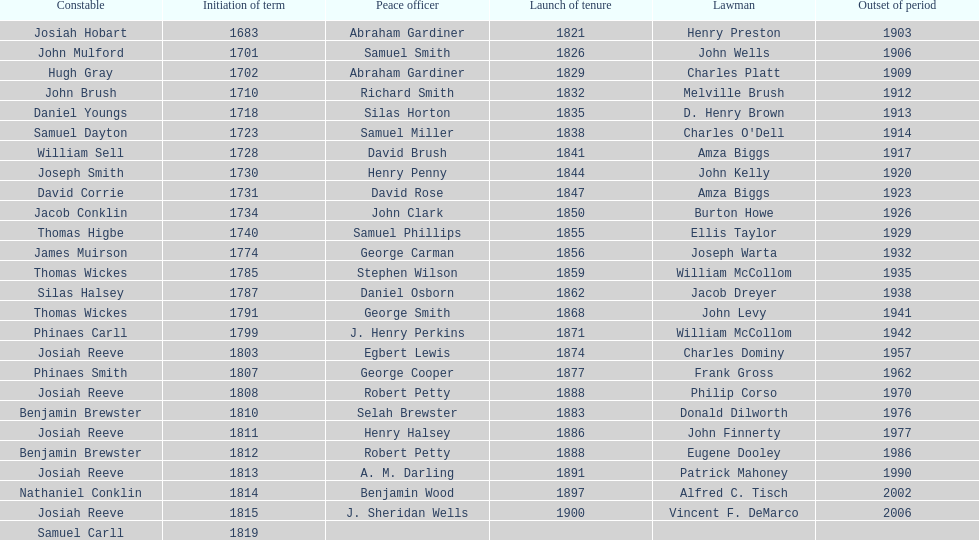When did benjamin brewster serve his second term? 1812. 